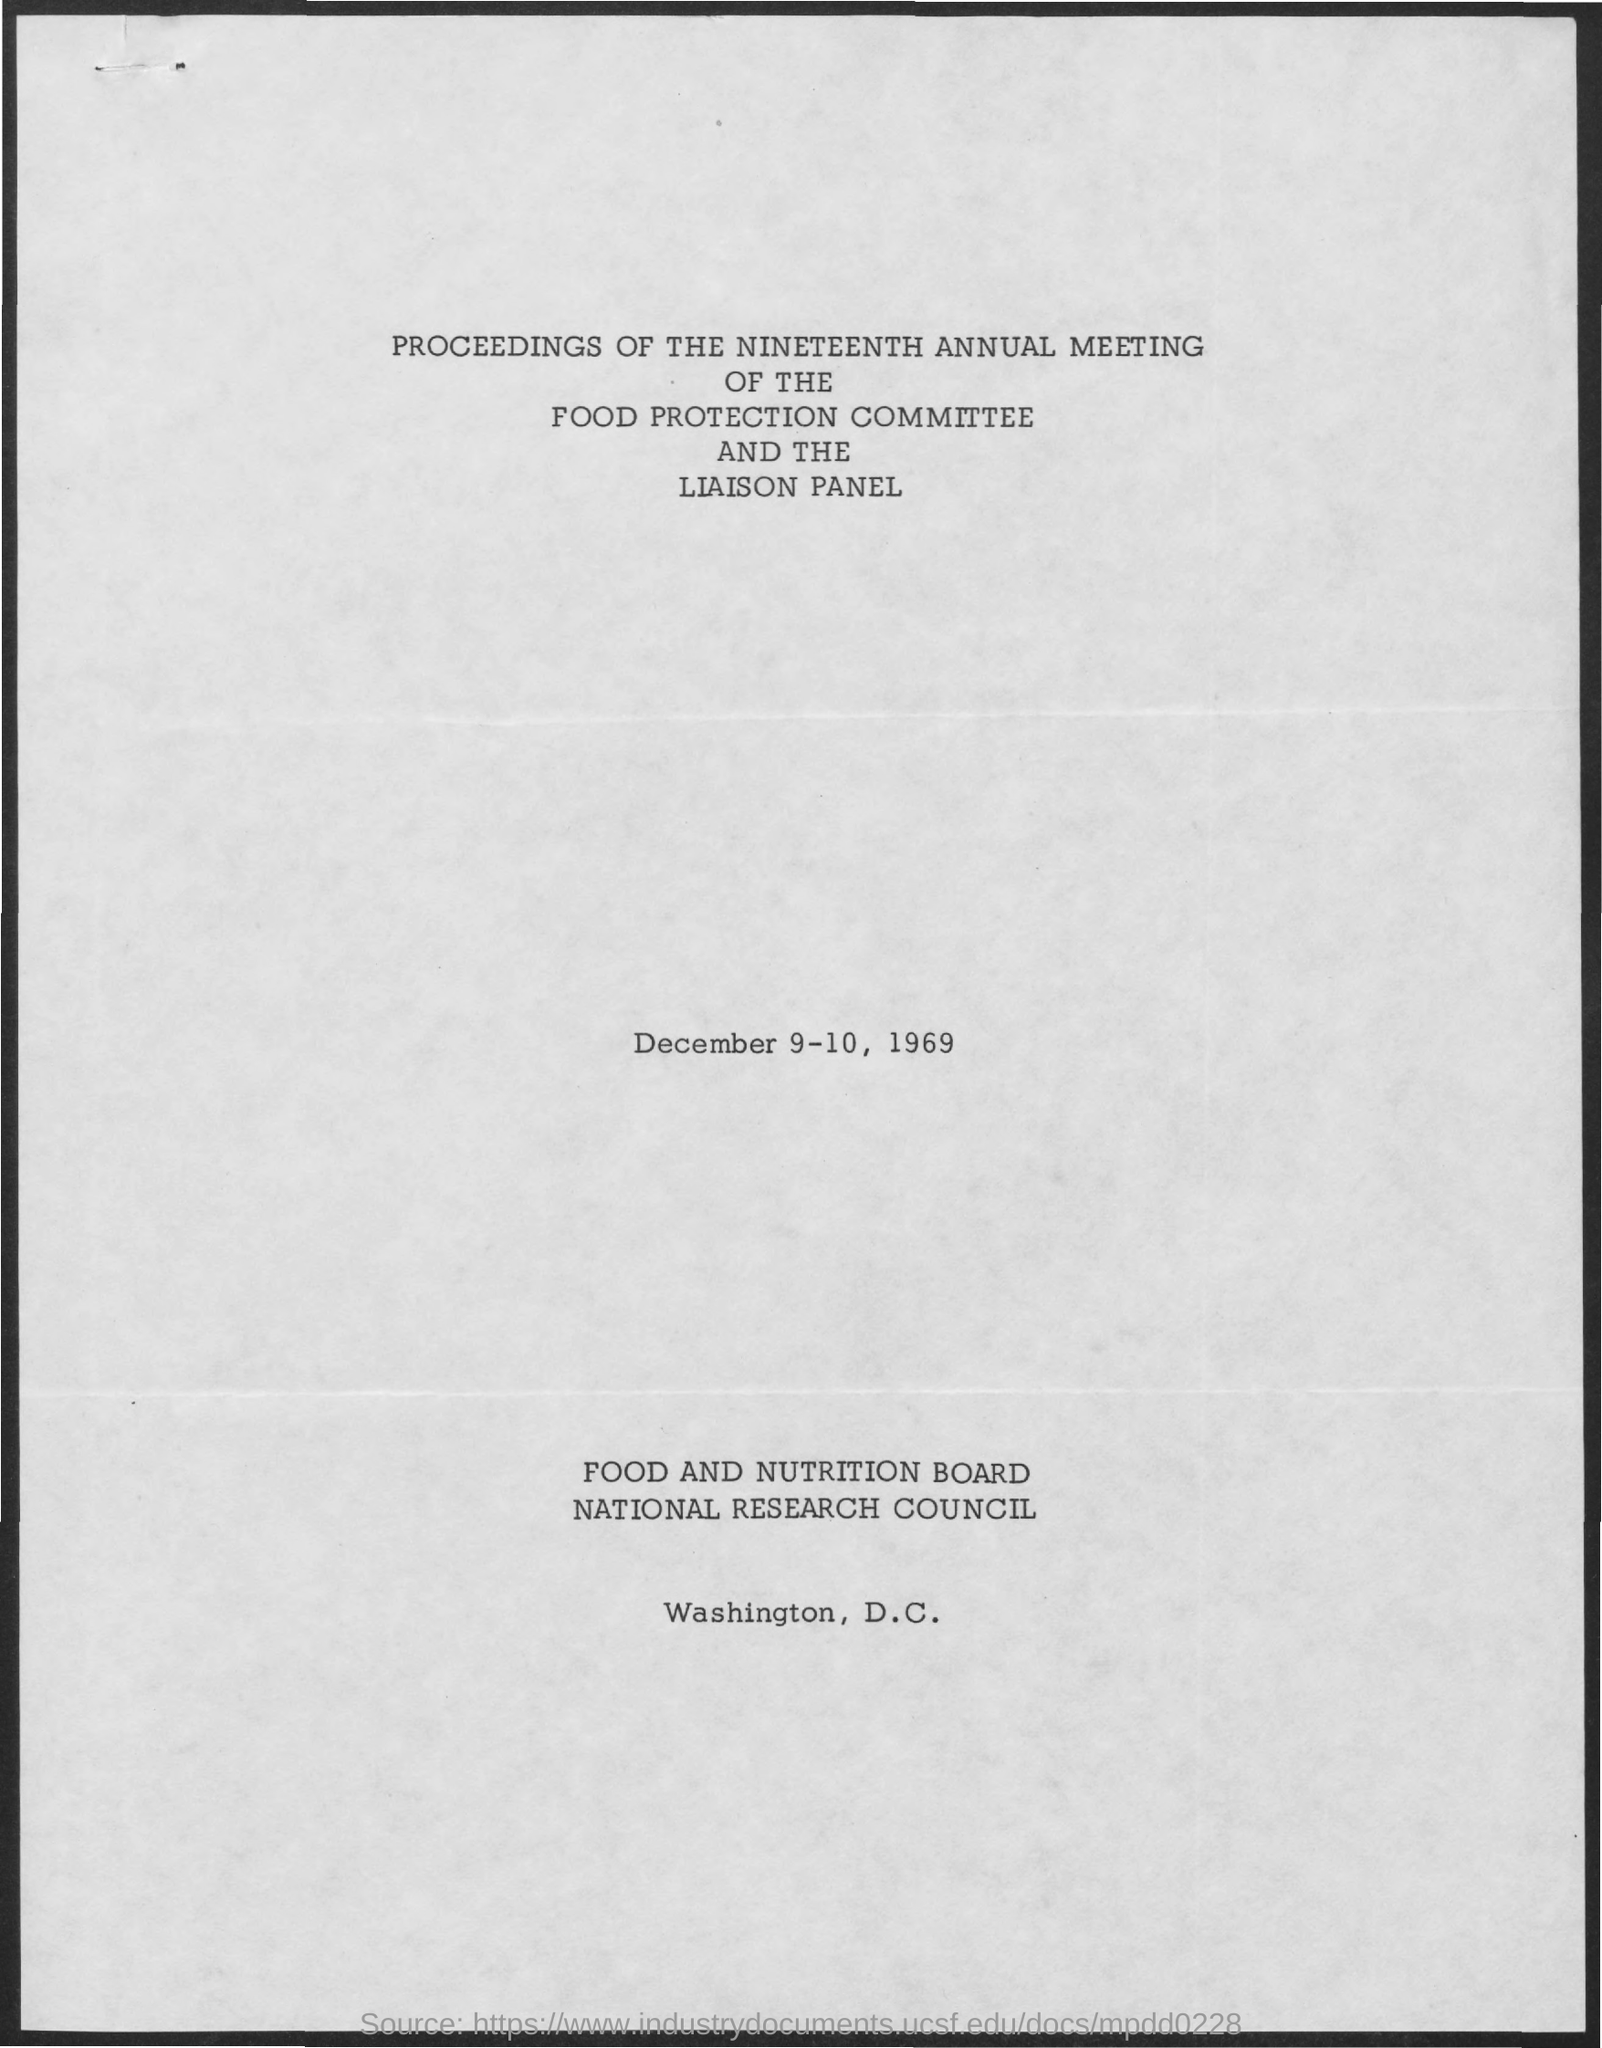When is the nineteenth annual meeting of the food protection committee and the liaison panel held?
Your answer should be compact. December 9-10, 1969. 